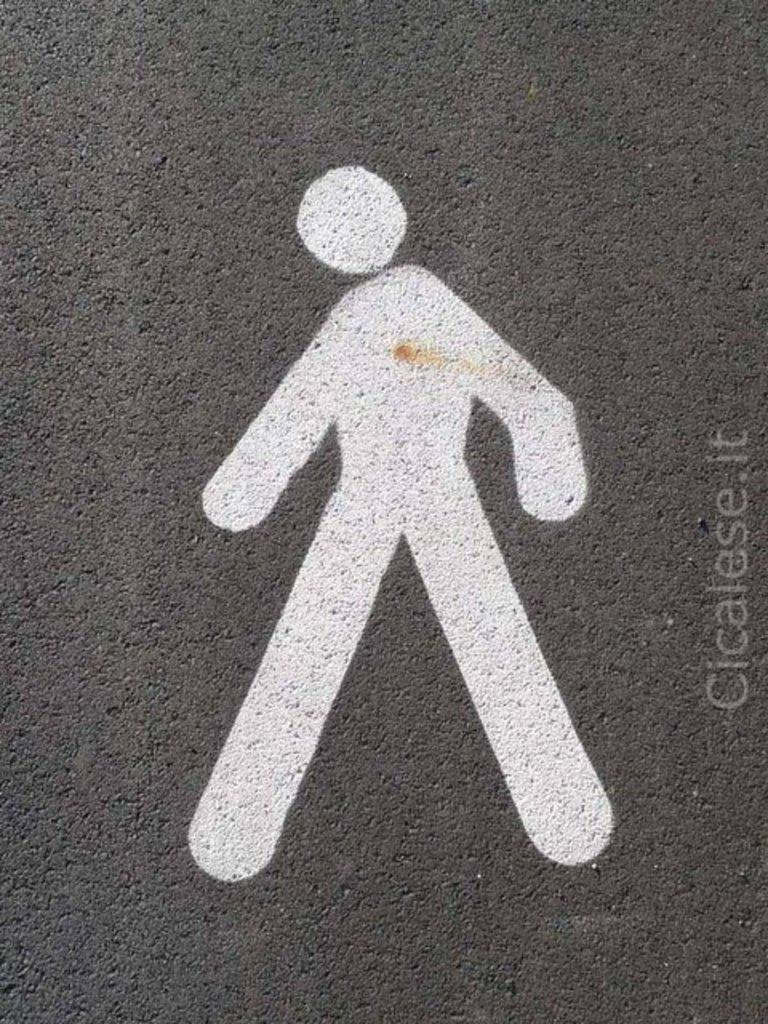What is depicted on the concrete surface in the image? There is a painting on a concrete surface in the image. Can you describe the painting in the image? Unfortunately, the facts provided do not give a detailed description of the painting. What else is present in the image besides the painting? There is some text in the image. How does the mist affect the painting in the image? There is no mention of mist in the image, so we cannot answer this question. 